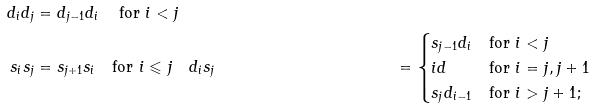<formula> <loc_0><loc_0><loc_500><loc_500>d _ { i } d _ { j } & = d _ { j - 1 } d _ { i } \quad \, \text {for $i < j$} \\ s _ { i } s _ { j } & = s _ { j + 1 } s _ { i } \quad \text {for $i \leqslant j$} \quad d _ { i } s _ { j } & = \begin{cases} s _ { j - 1 } d _ { i } & \text {for $i < j$} \\ i d & \text {for $i = j, j+1$} \\ s _ { j } d _ { i - 1 } & \text {for $i > j+1$;} \end{cases}</formula> 